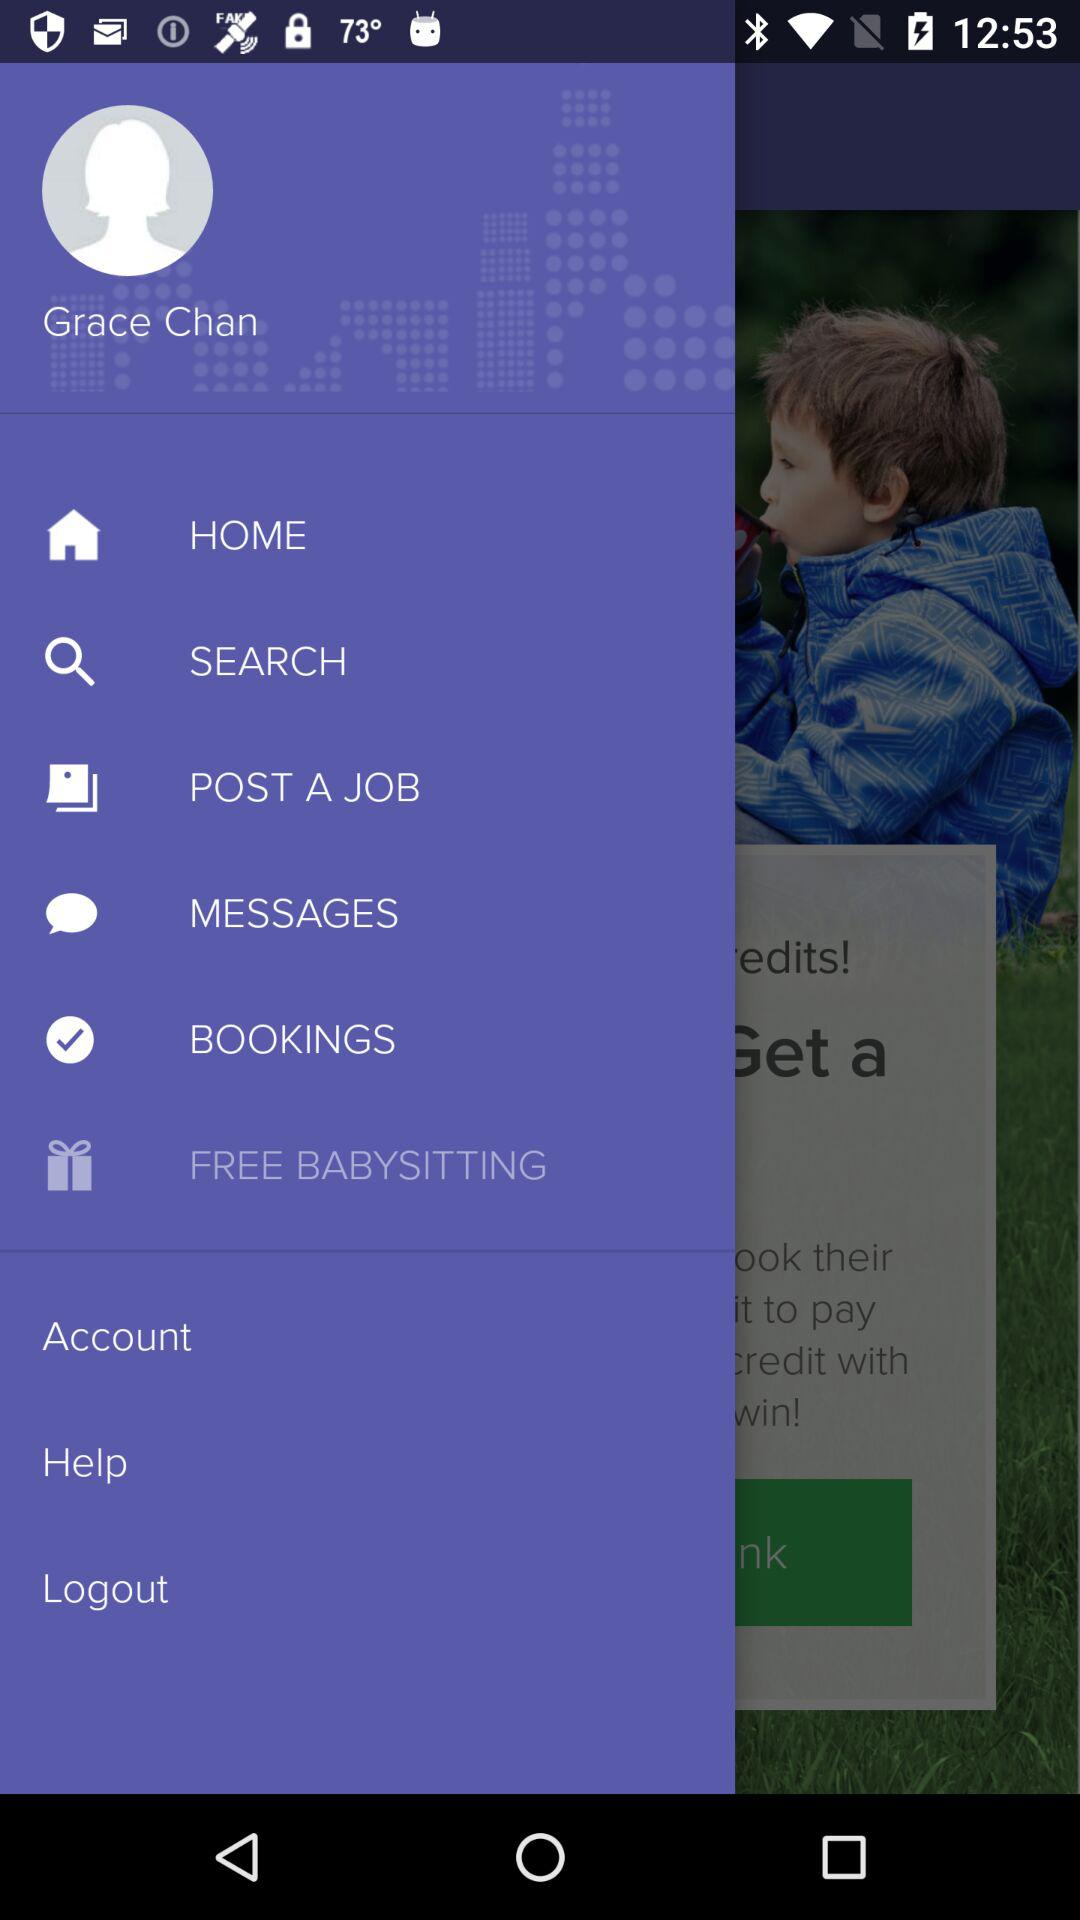Which item has been selected? The selected item is "FREE BABYSITTING". 